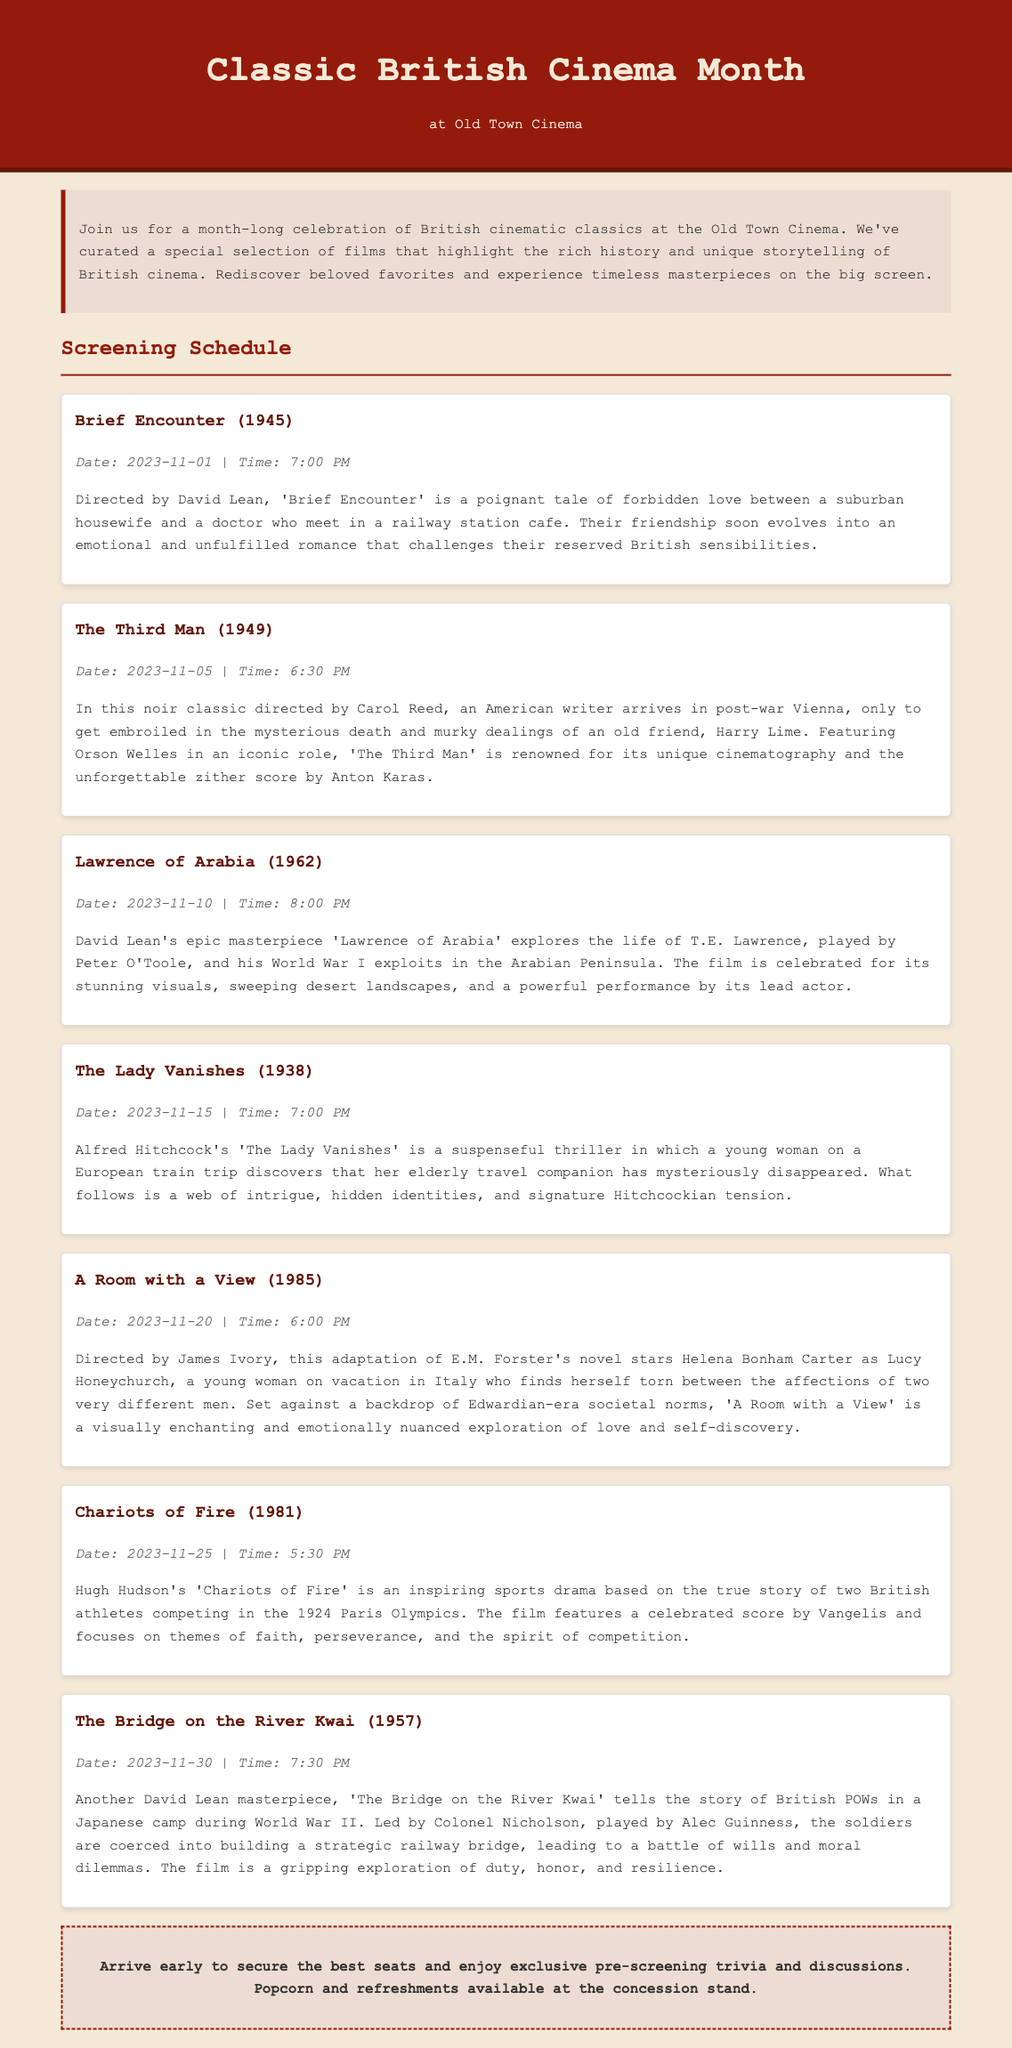What is the title of the first film screening? The first film screening listed in the document is 'Brief Encounter.'
Answer: Brief Encounter What date is 'The Third Man' scheduled to screen? The screening date for 'The Third Man' is specified in the document as November 5, 2023.
Answer: 2023-11-05 What time does 'Lawrence of Arabia' begin? The document provides the screening start time for 'Lawrence of Arabia' as 8:00 PM.
Answer: 8:00 PM Which director made 'The Lady Vanishes'? The film 'The Lady Vanishes' was directed by Alfred Hitchcock, as indicated in the document.
Answer: Alfred Hitchcock How many films are listed in the screening schedule? The document mentions a total of six films included in the screening schedule.
Answer: 6 What theme is explored in 'Chariots of Fire'? The document notes that 'Chariots of Fire' explores themes of faith, perseverance, and the spirit of competition.
Answer: faith, perseverance, and the spirit of competition What type of event is being celebrated in the document? The document indicates a month-long celebration of British cinematic classics.
Answer: British cinematic classics What is available at the concession stand? The document mentions popcorn and refreshments being available at the concession stand.
Answer: popcorn and refreshments 